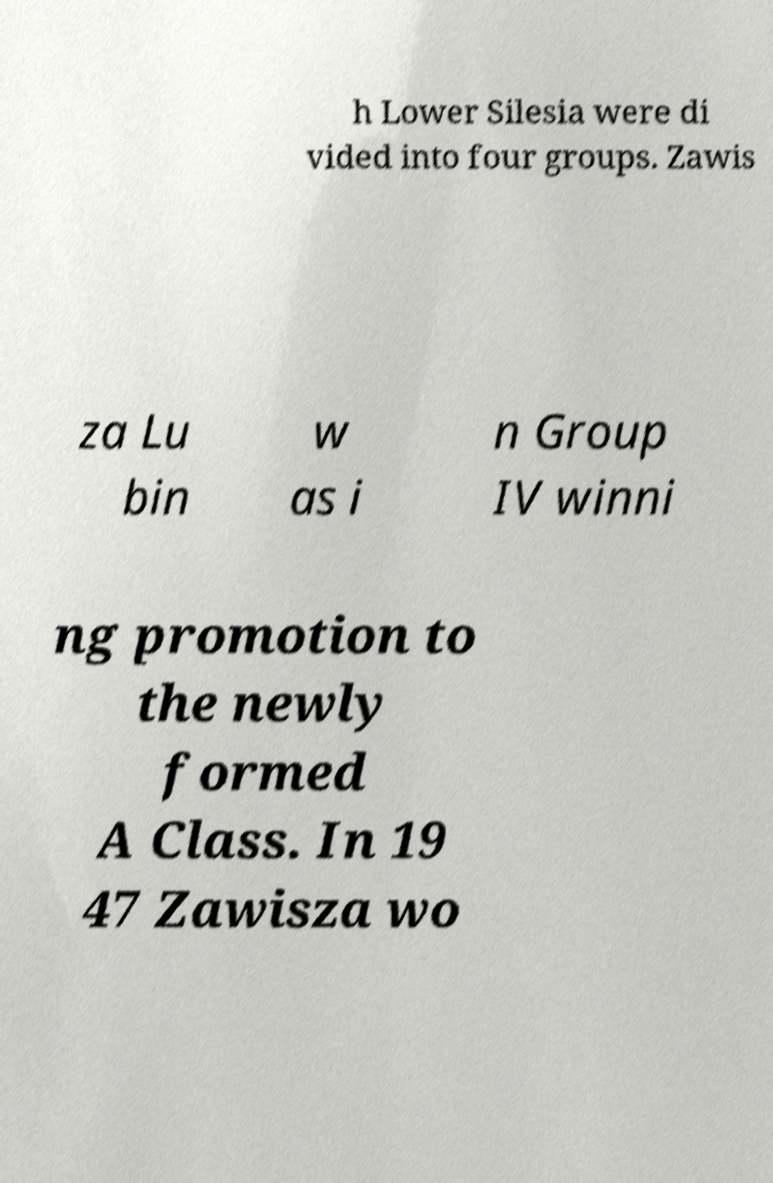Can you read and provide the text displayed in the image?This photo seems to have some interesting text. Can you extract and type it out for me? h Lower Silesia were di vided into four groups. Zawis za Lu bin w as i n Group IV winni ng promotion to the newly formed A Class. In 19 47 Zawisza wo 